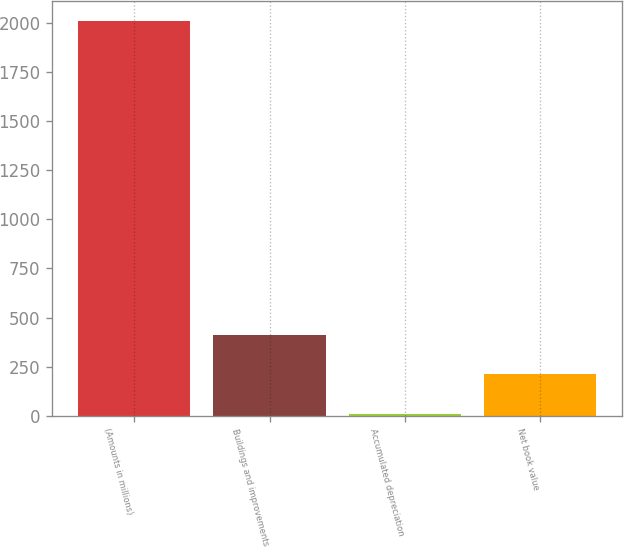Convert chart. <chart><loc_0><loc_0><loc_500><loc_500><bar_chart><fcel>(Amounts in millions)<fcel>Buildings and improvements<fcel>Accumulated depreciation<fcel>Net book value<nl><fcel>2012<fcel>411.44<fcel>11.3<fcel>211.37<nl></chart> 